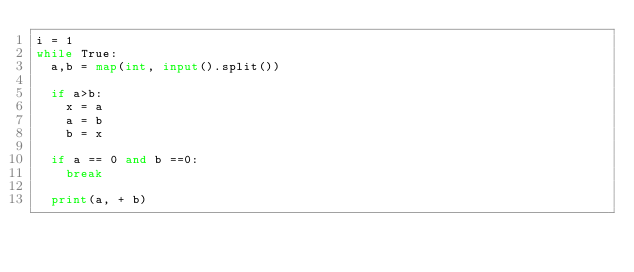Convert code to text. <code><loc_0><loc_0><loc_500><loc_500><_Python_>i = 1
while True:
  a,b = map(int, input().split())
  
  if a>b:
    x = a
    a = b
    b = x
    
  if a == 0 and b ==0:
    break
  
  print(a, + b)
</code> 